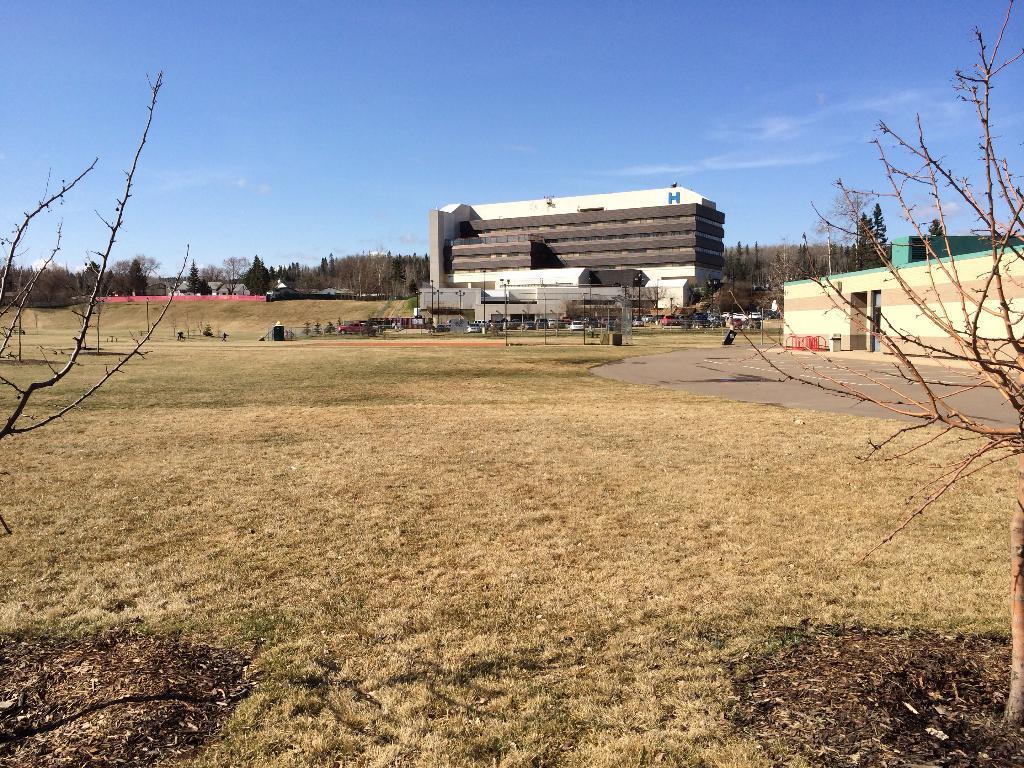How would you summarize this image in a sentence or two? In this picture we can see grass at the bottom, in the background there are some buildings and trees, we can see some poles in the middle, there is the sky at the top of the picture. 